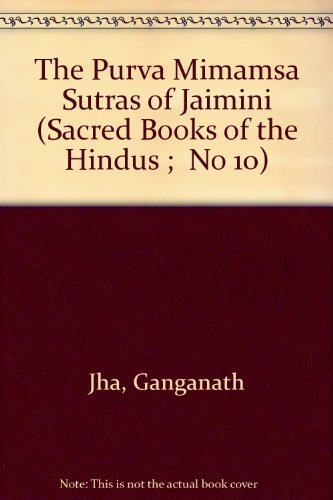What is the genre of this book? This book belongs to the genre of Religion & Spirituality, delving into the complexities of ancient Hindu philosophy and rituals. 